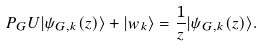<formula> <loc_0><loc_0><loc_500><loc_500>P _ { G } U | \psi _ { G , k } ( z ) \rangle + | w _ { k } \rangle = \frac { 1 } { z } | \psi _ { G , k } ( z ) \rangle .</formula> 